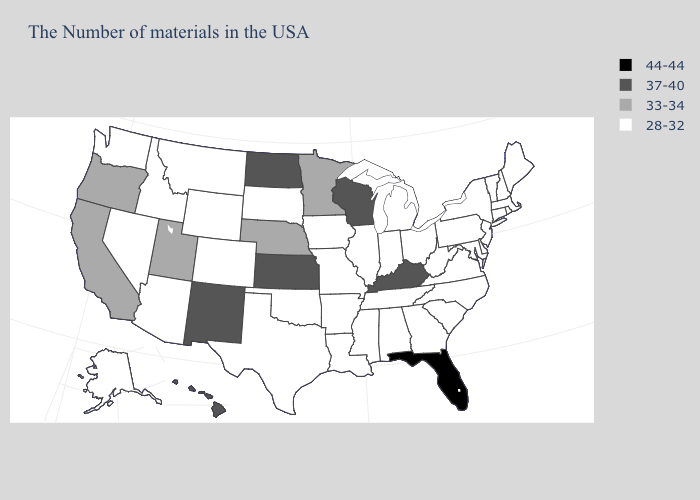Name the states that have a value in the range 33-34?
Answer briefly. Minnesota, Nebraska, Utah, California, Oregon. Name the states that have a value in the range 33-34?
Concise answer only. Minnesota, Nebraska, Utah, California, Oregon. Name the states that have a value in the range 33-34?
Keep it brief. Minnesota, Nebraska, Utah, California, Oregon. What is the value of Nebraska?
Be succinct. 33-34. How many symbols are there in the legend?
Keep it brief. 4. What is the value of Hawaii?
Keep it brief. 37-40. What is the value of Oregon?
Concise answer only. 33-34. Does Indiana have a higher value than Nebraska?
Write a very short answer. No. Name the states that have a value in the range 44-44?
Give a very brief answer. Florida. Among the states that border Washington , does Idaho have the lowest value?
Keep it brief. Yes. Name the states that have a value in the range 28-32?
Be succinct. Maine, Massachusetts, Rhode Island, New Hampshire, Vermont, Connecticut, New York, New Jersey, Delaware, Maryland, Pennsylvania, Virginia, North Carolina, South Carolina, West Virginia, Ohio, Georgia, Michigan, Indiana, Alabama, Tennessee, Illinois, Mississippi, Louisiana, Missouri, Arkansas, Iowa, Oklahoma, Texas, South Dakota, Wyoming, Colorado, Montana, Arizona, Idaho, Nevada, Washington, Alaska. Name the states that have a value in the range 37-40?
Be succinct. Kentucky, Wisconsin, Kansas, North Dakota, New Mexico, Hawaii. What is the lowest value in states that border Idaho?
Short answer required. 28-32. Which states have the highest value in the USA?
Short answer required. Florida. What is the highest value in the USA?
Write a very short answer. 44-44. 